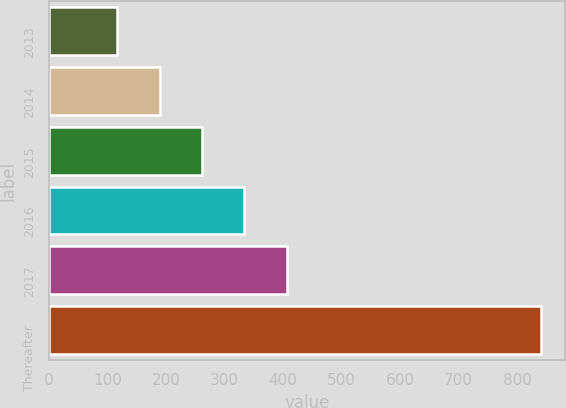<chart> <loc_0><loc_0><loc_500><loc_500><bar_chart><fcel>2013<fcel>2014<fcel>2015<fcel>2016<fcel>2017<fcel>Thereafter<nl><fcel>117<fcel>189.3<fcel>261.6<fcel>333.9<fcel>406.2<fcel>840<nl></chart> 